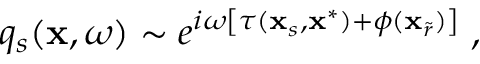<formula> <loc_0><loc_0><loc_500><loc_500>q _ { s } ( x , \omega ) \sim e ^ { i \omega \left [ \tau ( x _ { s } , x ^ { * } ) + \phi ( x _ { \widetilde { r } } ) \right ] } \, ,</formula> 